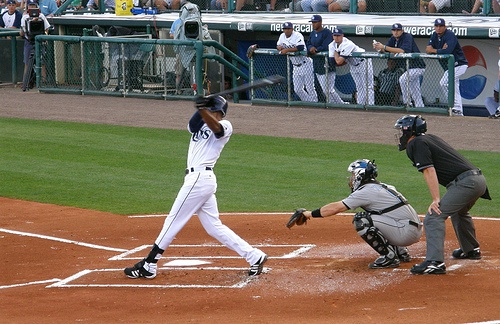Describe the objects in this image and their specific colors. I can see people in gray, lavender, black, and darkgray tones, people in gray, black, and darkgreen tones, people in gray, darkgray, black, and lightgray tones, people in gray, black, and darkgray tones, and people in gray, lavender, and darkgray tones in this image. 